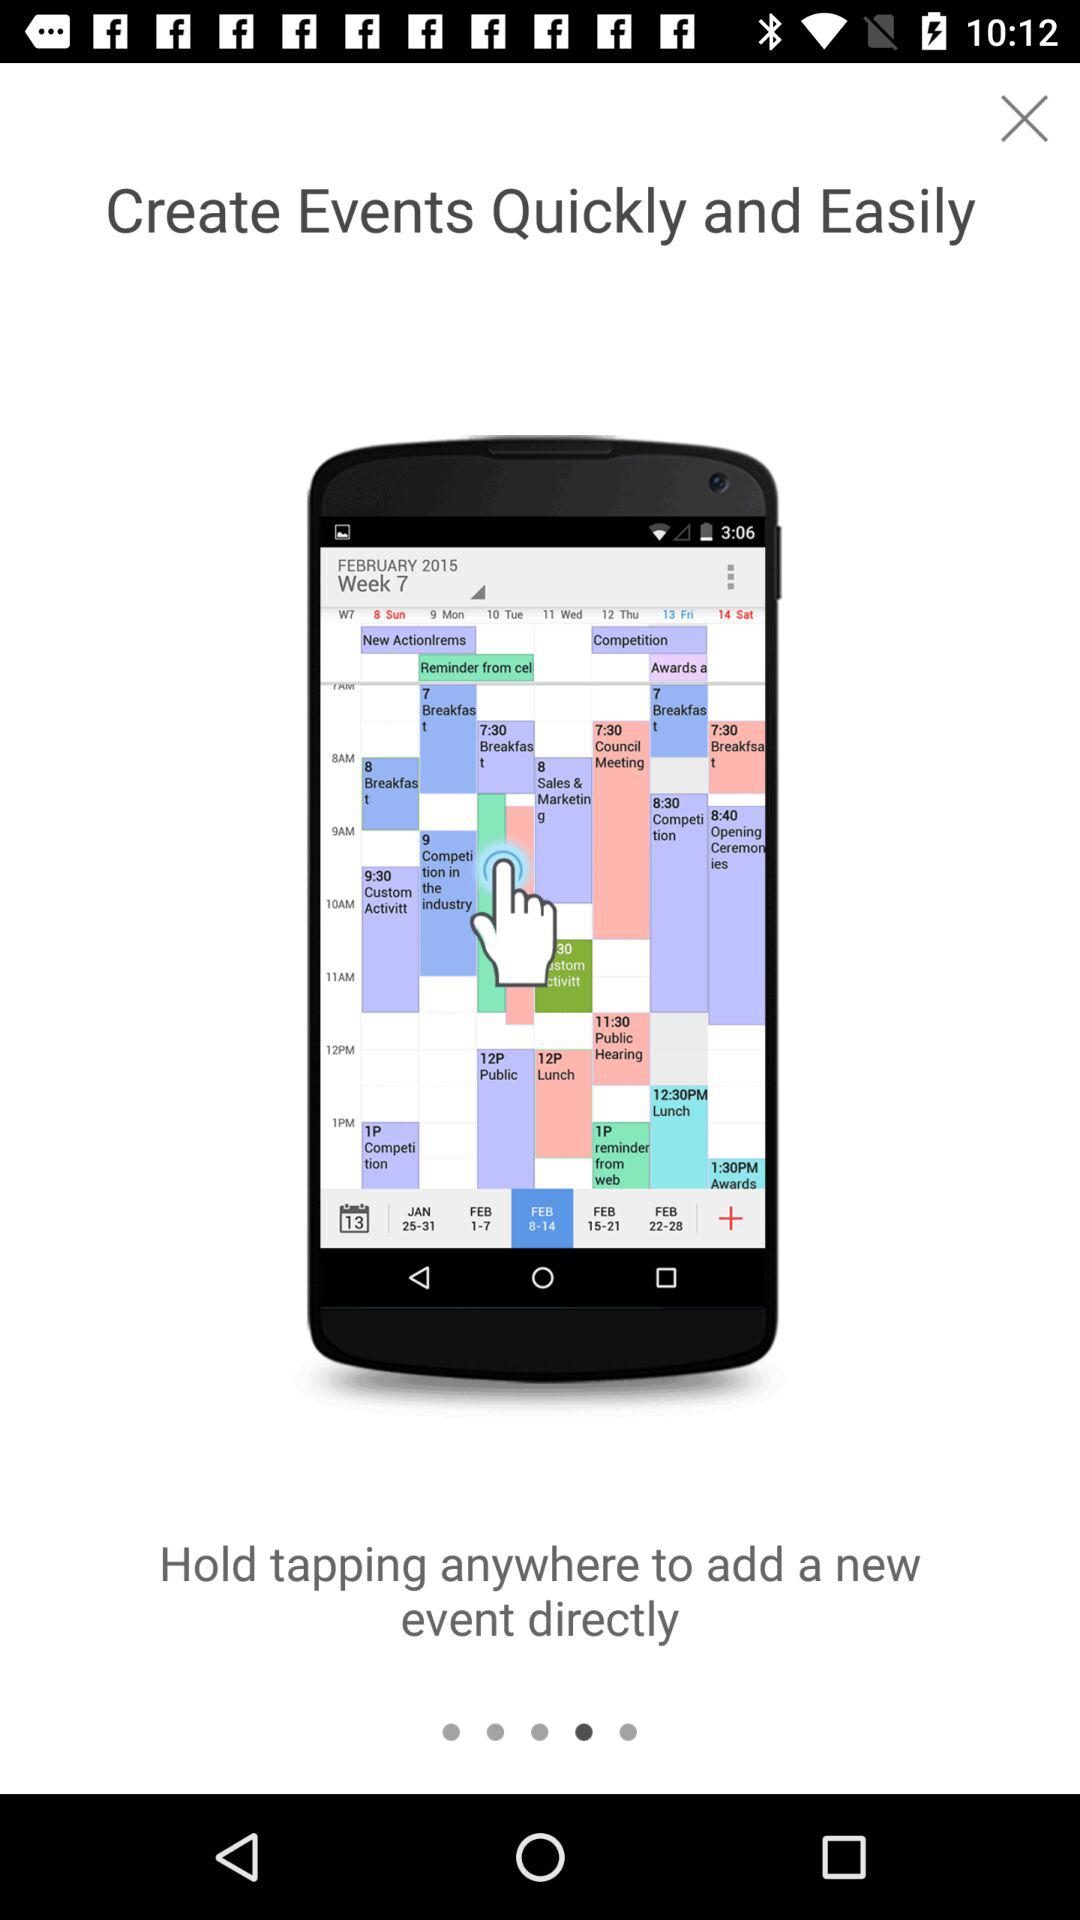How long must we hold tapping to add a new event?
When the provided information is insufficient, respond with <no answer>. <no answer> 